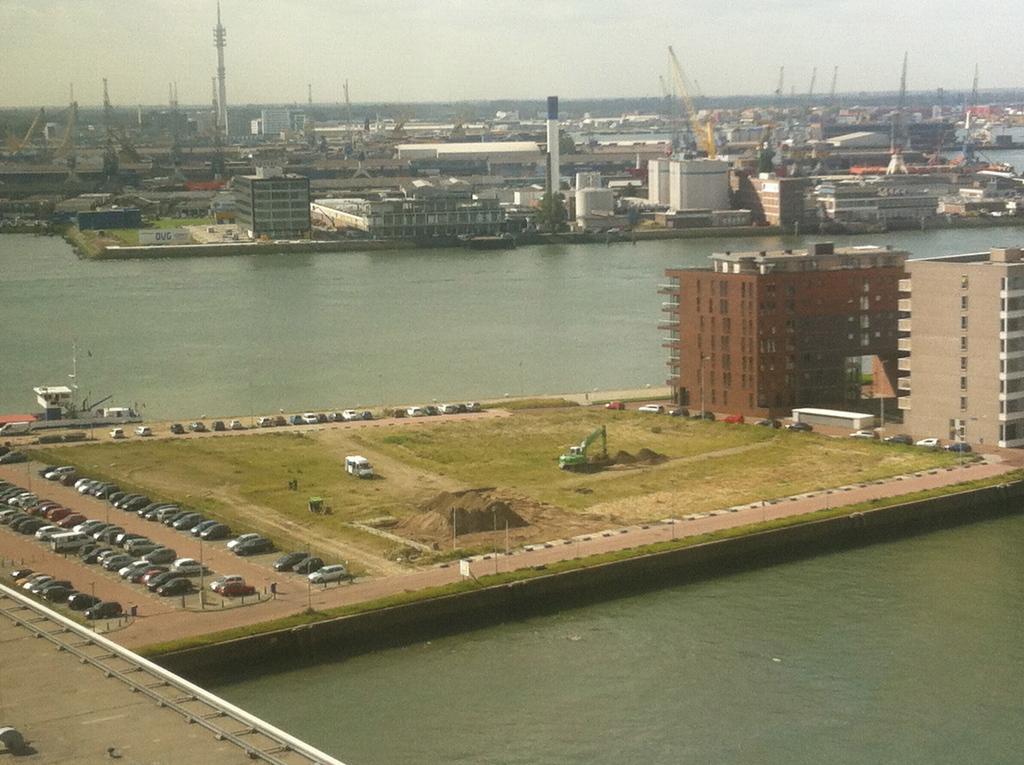Please provide a concise description of this image. In this image at the center cars were parked on the road. At the back side there are buildings. On both right and left side of the building there is water. At the background there are buildings, cranes and at the top there is sky. 